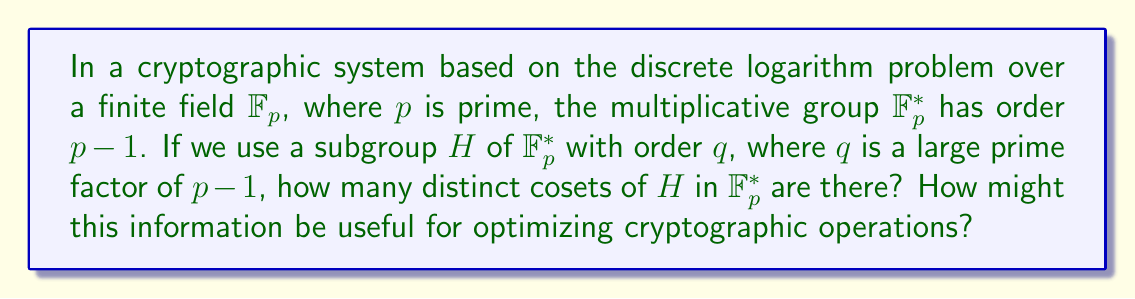Can you answer this question? To solve this problem, we'll use the following steps:

1) First, recall Lagrange's Theorem, which states that for a finite group $G$ and a subgroup $H$ of $G$, the order of $H$ divides the order of $G$. In other words:

   $$ |G| = |H| \cdot [G:H] $$

   where $[G:H]$ is the index of $H$ in $G$, which is equal to the number of distinct cosets of $H$ in $G$.

2) In our case, $G = \mathbb{F}_p^*$ and $|G| = p-1$.

3) We're given that $H$ is a subgroup of $\mathbb{F}_p^*$ with order $q$, where $q$ is a prime factor of $p-1$.

4) Applying Lagrange's Theorem:

   $$ p-1 = q \cdot [G:H] $$

5) Solving for $[G:H]$:

   $$ [G:H] = \frac{p-1}{q} $$

6) This fraction $\frac{p-1}{q}$ is an integer because $q$ is a factor of $p-1$.

7) The number of distinct cosets of $H$ in $\mathbb{F}_p^*$ is equal to $[G:H]$, which is $\frac{p-1}{q}$.

This information can be useful for optimizing cryptographic operations in several ways:

a) It allows for more efficient computations by working in the smaller subgroup of order $q$ instead of the full group of order $p-1$.

b) The number of cosets ($\frac{p-1}{q}$) represents the number of distinct "classes" of elements in $\mathbb{F}_p^*$ with respect to $H$. This can be used to reduce the search space in certain cryptographic attacks.

c) Understanding the coset structure can aid in the implementation of more efficient algorithms for exponentiation, which is a crucial operation in many cryptographic protocols based on the discrete logarithm problem.
Answer: The number of distinct cosets of $H$ in $\mathbb{F}_p^*$ is $\frac{p-1}{q}$. 